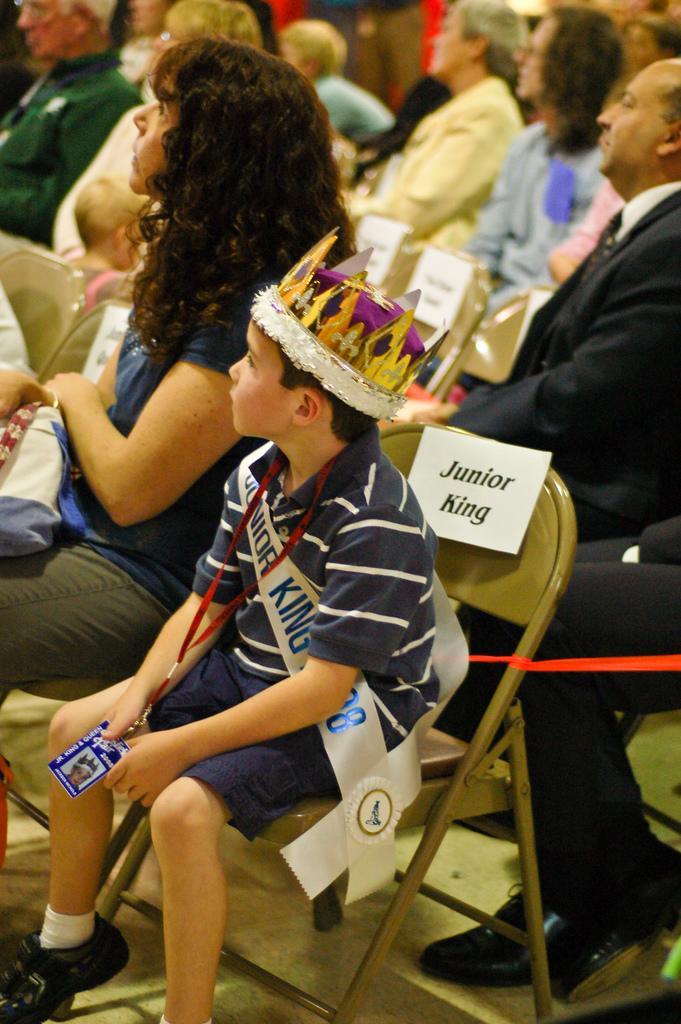Can you describe this image briefly? In this image we can see people sitting. The boy sitting in the center is wearing a crown. 